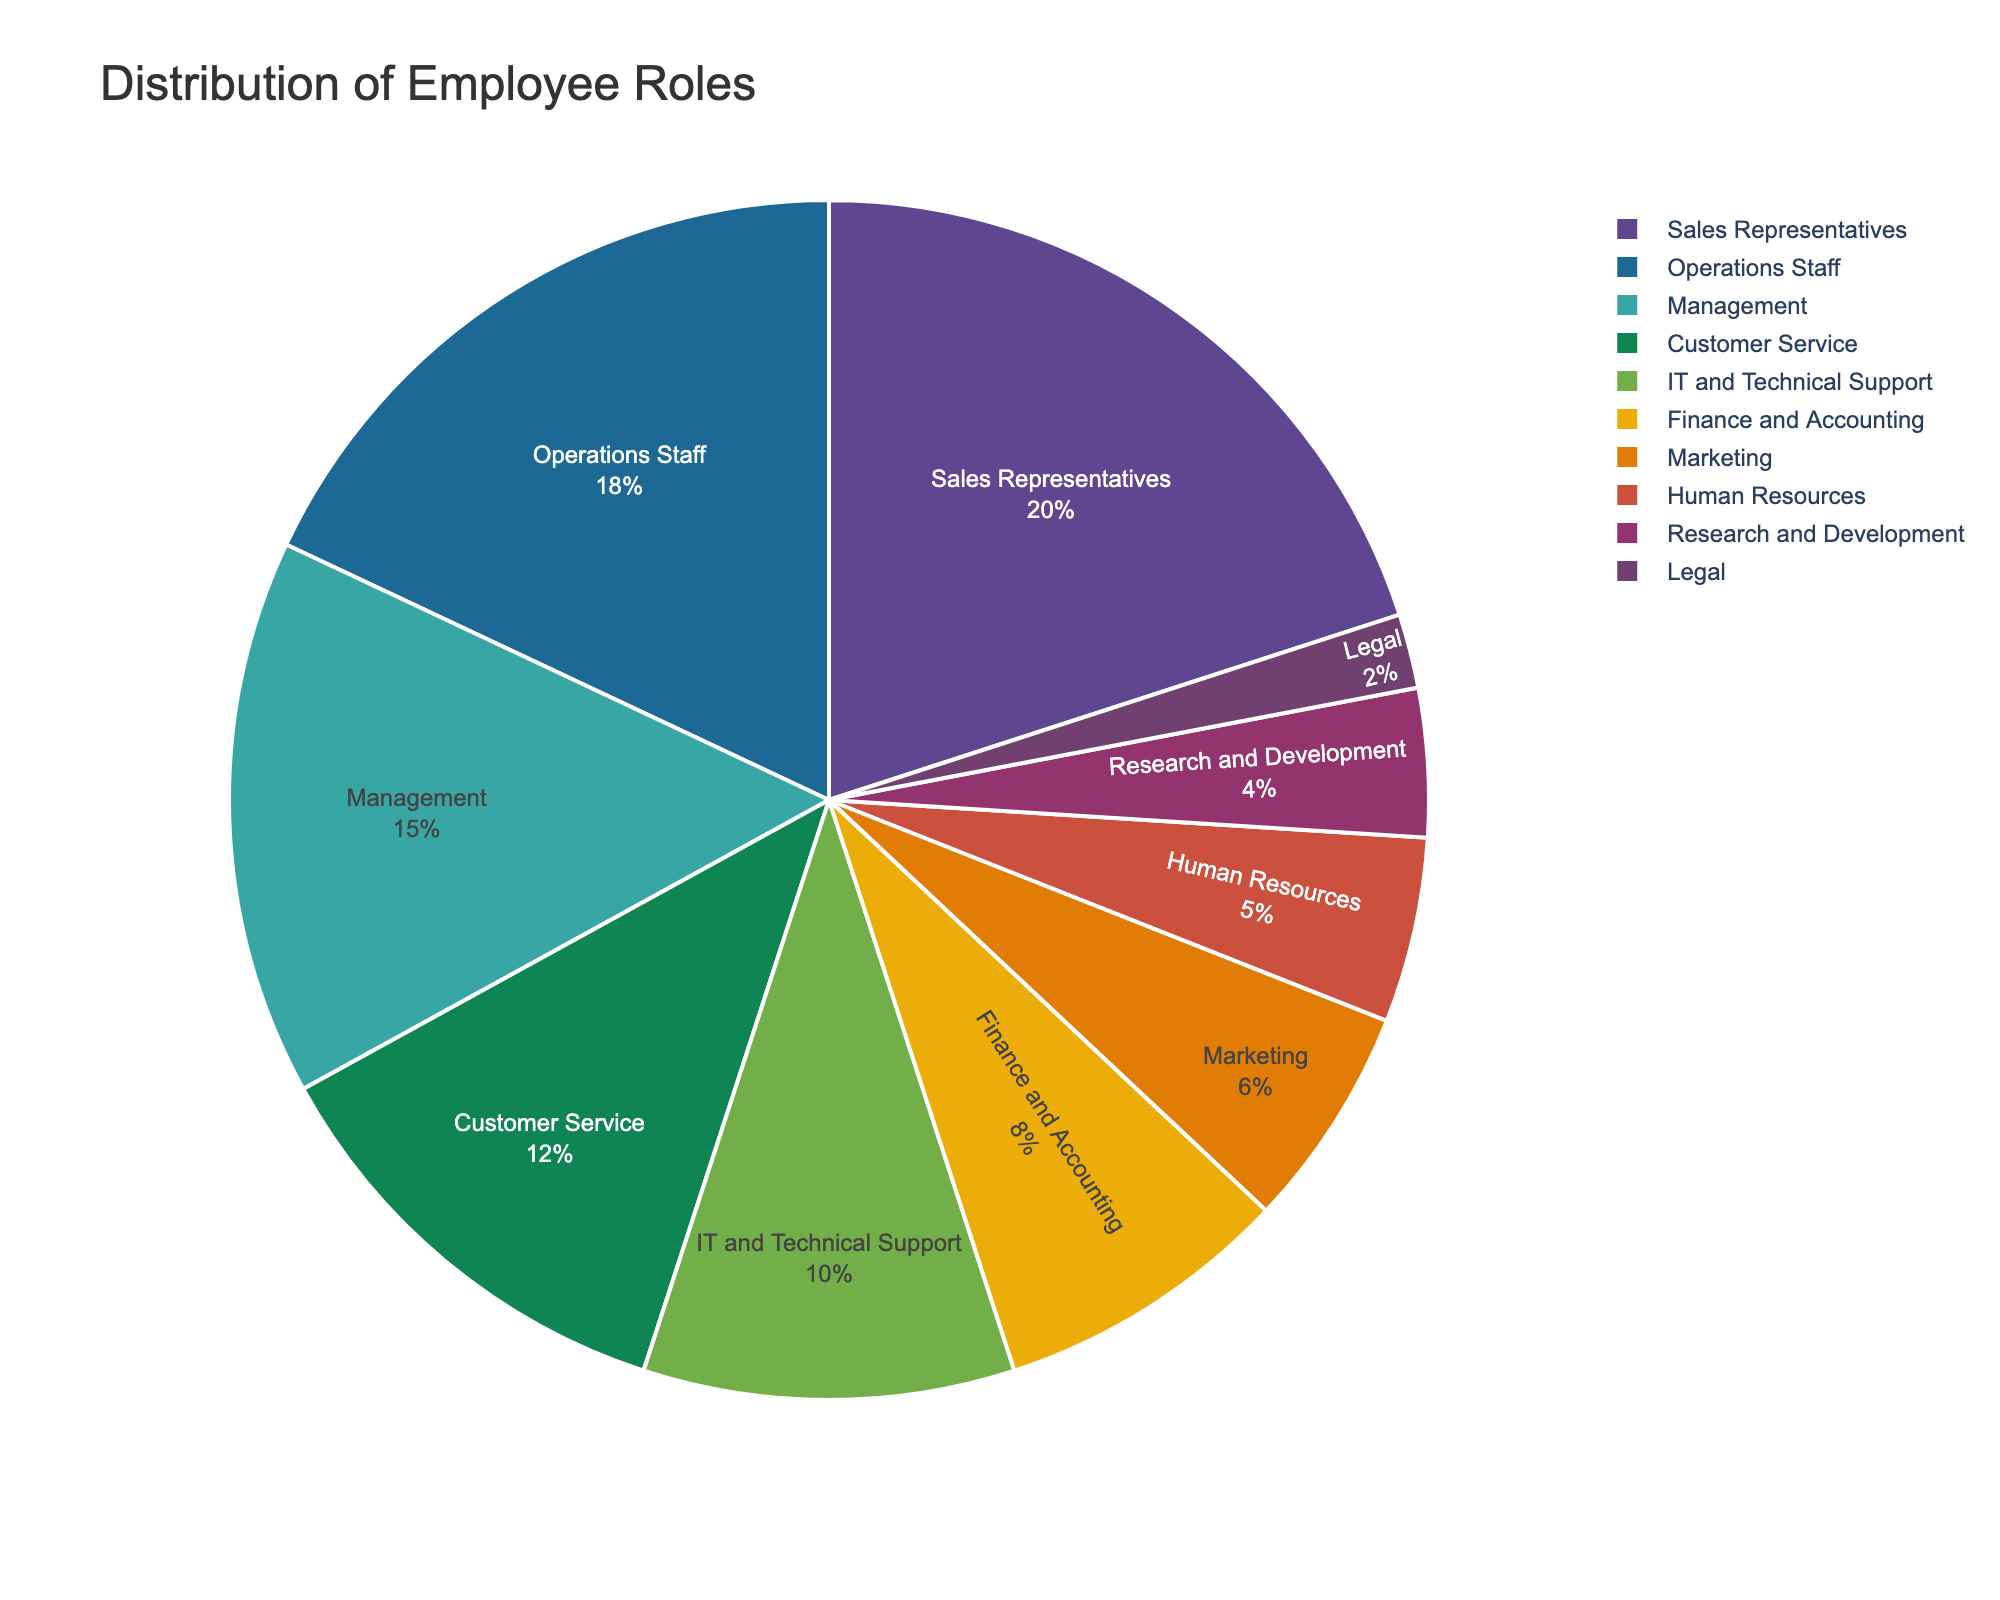Which role has the highest percentage? The pie chart shows the distribution of employee roles, and the largest section represents the Sales Representatives with a 20% share.
Answer: Sales Representatives Which role has the lowest percentage? The smallest section in the pie chart corresponds to the Legal department, which holds a 2% share.
Answer: Legal What is the combined percentage of Management and Sales Representatives? The chart shows that Management has 15% and Sales Representatives have 20%. Summing these gives 15% + 20% = 35%.
Answer: 35% How much greater is the percentage of Operations Staff compared to Finance and Accounting? Operations Staff has 18% and Finance and Accounting has 8%. The difference is 18% - 8% = 10%.
Answer: 10% What is the total percentage of Customer Service, IT and Technical Support, and Human Resources? Customer Service is 12%, IT and Technical Support is 10%, and Human Resources is 5%. Summing these values gives 12% + 10% + 5% = 27%.
Answer: 27% How many roles have a percentage less than 10%? The chart shows Finance and Accounting (8%), Human Resources (5%), Marketing (6%), Research and Development (4%), and Legal (2%). This totals 5 roles.
Answer: 5 What is the difference in percentage between Marketing and Research and Development? Marketing has a 6% share, whereas Research and Development has 4%. The difference is 6% - 4% = 2%.
Answer: 2% Which roles have percentages that are visually represented with different shades of red? By examining the colors in the pie chart, we can identify the roles with different shades of red.
Answer: Management, Research and Development 